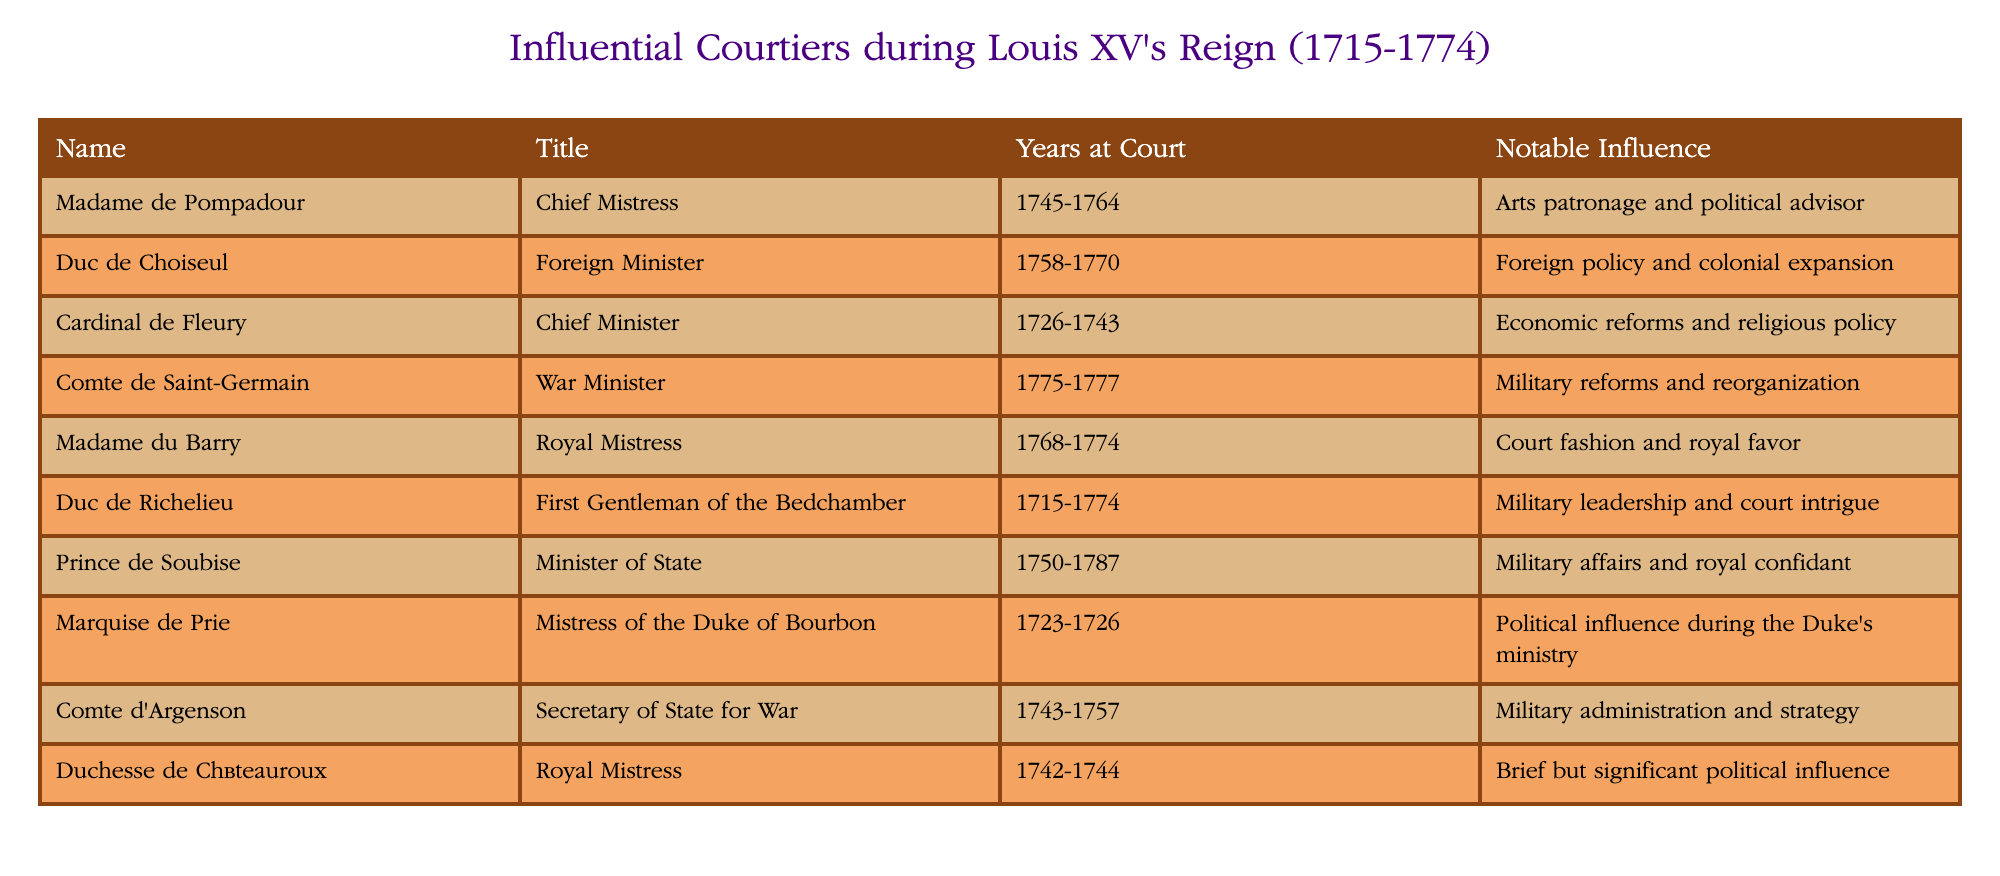What title did Madame de Pompadour hold? The title shown in the table for Madame de Pompadour is "Chief Mistress."
Answer: Chief Mistress Who served as Foreign Minister during Louis XV's reign? The table lists Duc de Choiseul as the Foreign Minister from 1758 to 1770.
Answer: Duc de Choiseul How long did Cardinal de Fleury serve at court? The table indicates that Cardinal de Fleury served at court from 1726 to 1743, which totals 17 years.
Answer: 17 years Is it true that the Comte d'Argenson was involved in military administration? Yes, the table states that Comte d'Argenson was the Secretary of State for War, involved in military administration and strategy.
Answer: Yes Who had notable influence in court fashion and royal favor? According to the table, Madame du Barry held notable influence in court fashion and royal favor during her time.
Answer: Madame du Barry What is the difference in years at court between Duc de Richelieu and Madame de Pompadour? Duc de Richelieu served from 1715 to 1774, totaling 59 years, while Madame de Pompadour served from 1745 to 1764, totaling 19 years. The difference is 59 - 19 = 40 years.
Answer: 40 years Which courtier had the shortest time at court and what was the duration? The Duchesse de Châteauroux is noted to have served from 1742 to 1744, giving her a duration of 2 years, which is the shortest on the list.
Answer: 2 years Name a royal mistress who was prominent in Louis XV's reign. Madame du Barry and Duchesse de Châteauroux are both listed as royal mistresses in the table.
Answer: Madame du Barry or Duchesse de Châteauroux How many influential courtiers had military roles? From the table, there are four courtiers listed with military roles: Comte de Saint-Germain, Duc de Richelieu, Comte d'Argenson, and Prince de Soubise.
Answer: 4 courtiers 